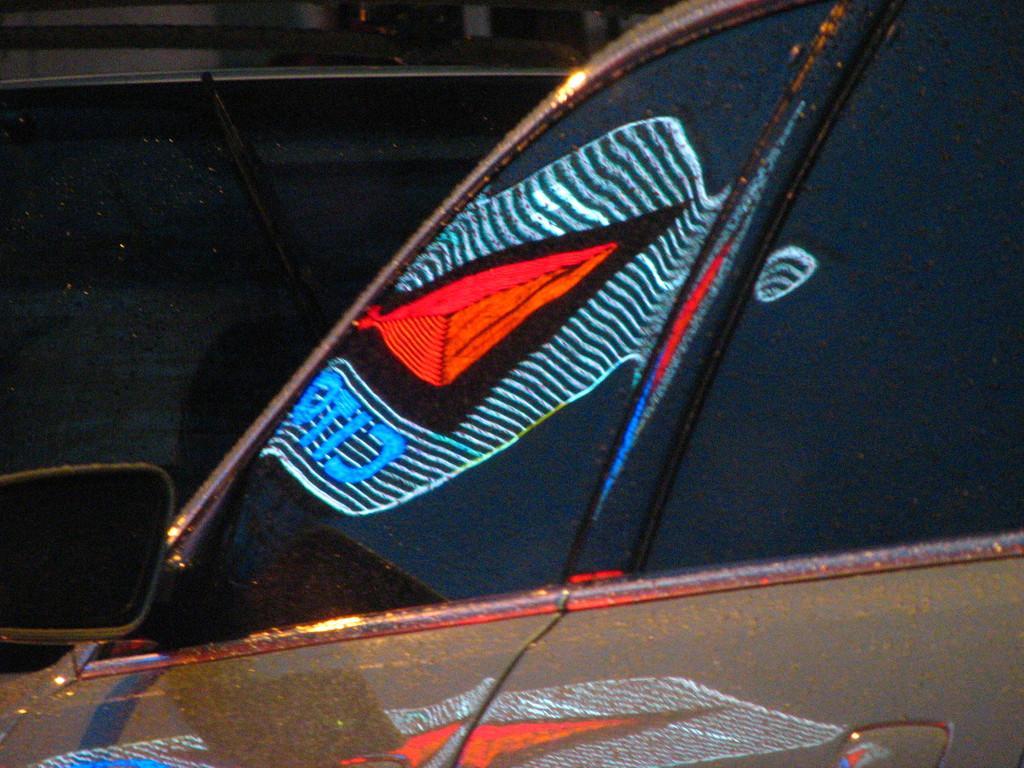How would you summarize this image in a sentence or two? In this image we can see cars. 